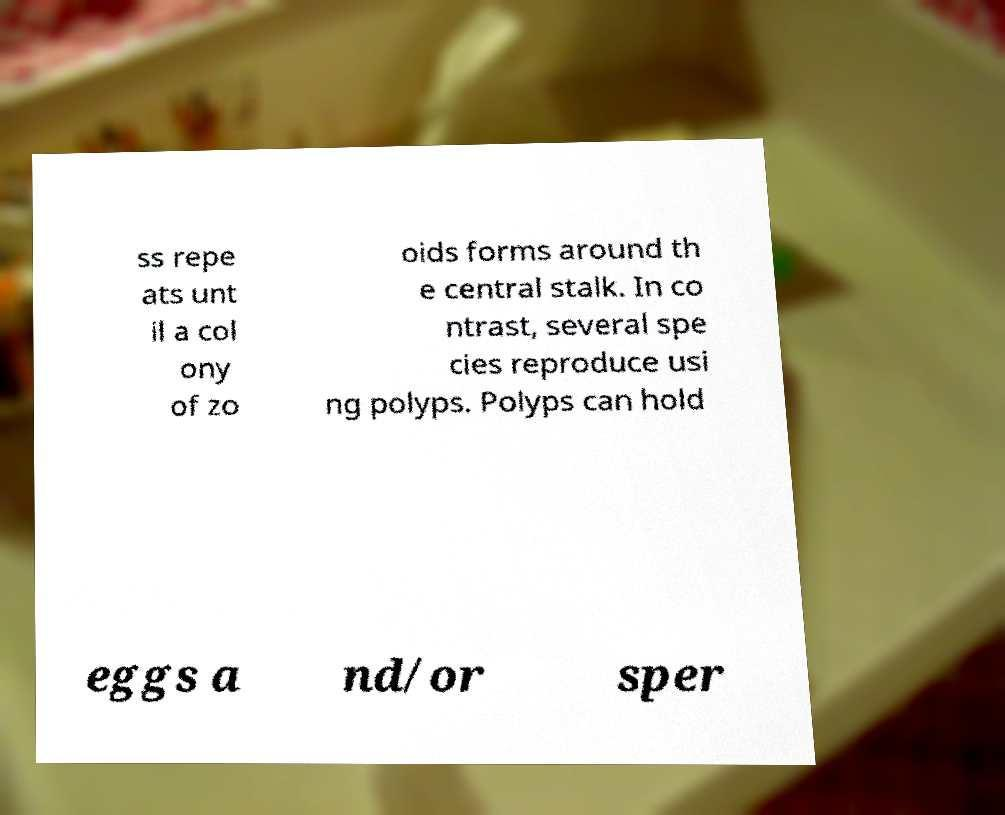Could you assist in decoding the text presented in this image and type it out clearly? ss repe ats unt il a col ony of zo oids forms around th e central stalk. In co ntrast, several spe cies reproduce usi ng polyps. Polyps can hold eggs a nd/or sper 